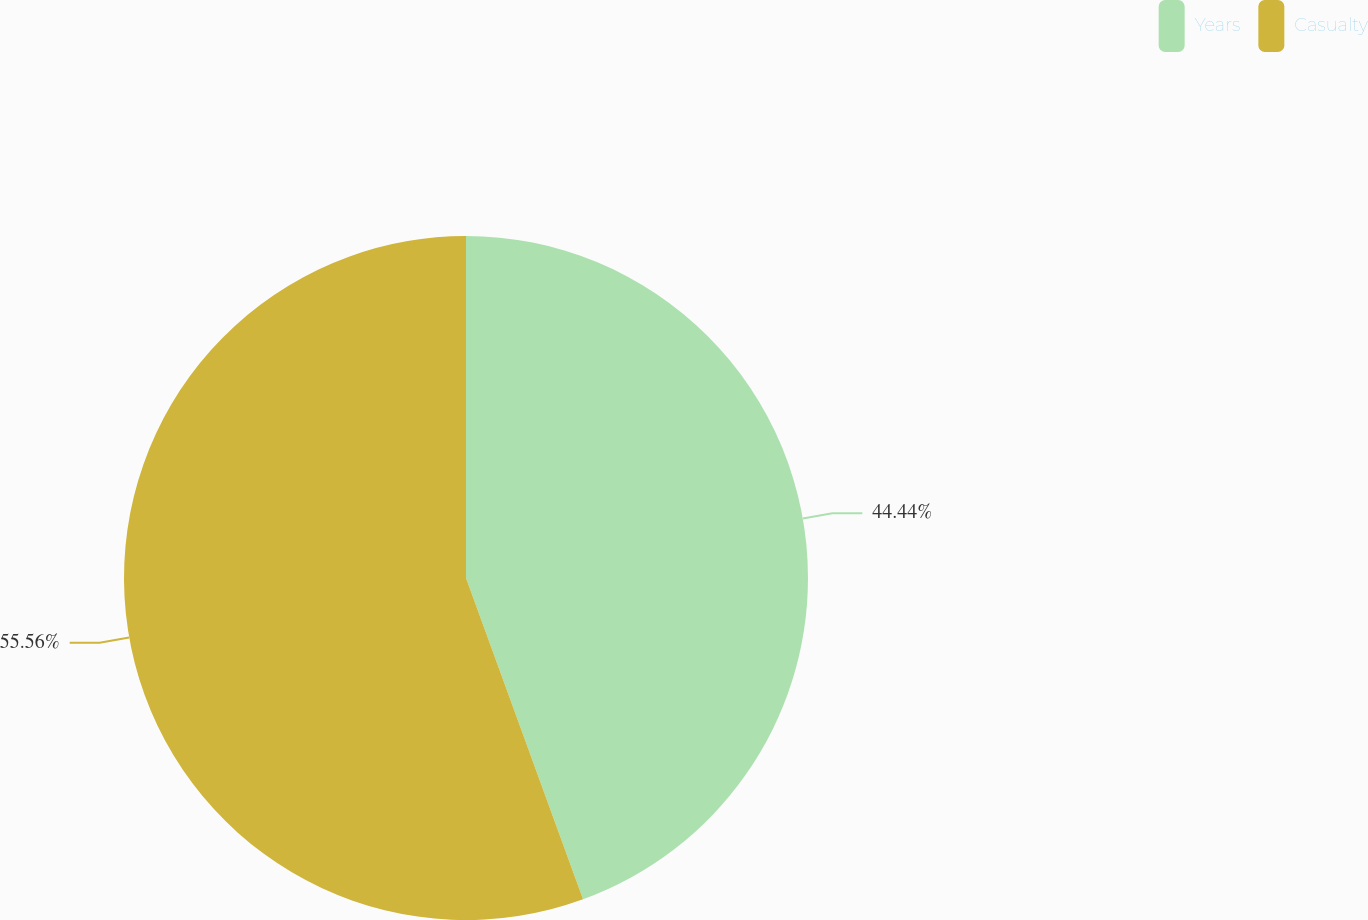<chart> <loc_0><loc_0><loc_500><loc_500><pie_chart><fcel>Years<fcel>Casualty<nl><fcel>44.44%<fcel>55.56%<nl></chart> 